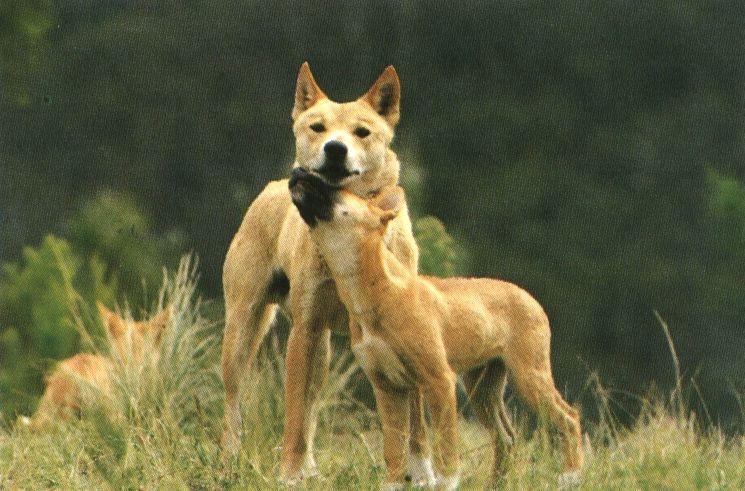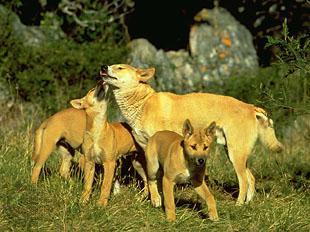The first image is the image on the left, the second image is the image on the right. Analyze the images presented: Is the assertion "There are more animals in the left image than there are in the right image." valid? Answer yes or no. No. The first image is the image on the left, the second image is the image on the right. Evaluate the accuracy of this statement regarding the images: "There's no more than one wild dog in the right image.". Is it true? Answer yes or no. No. 